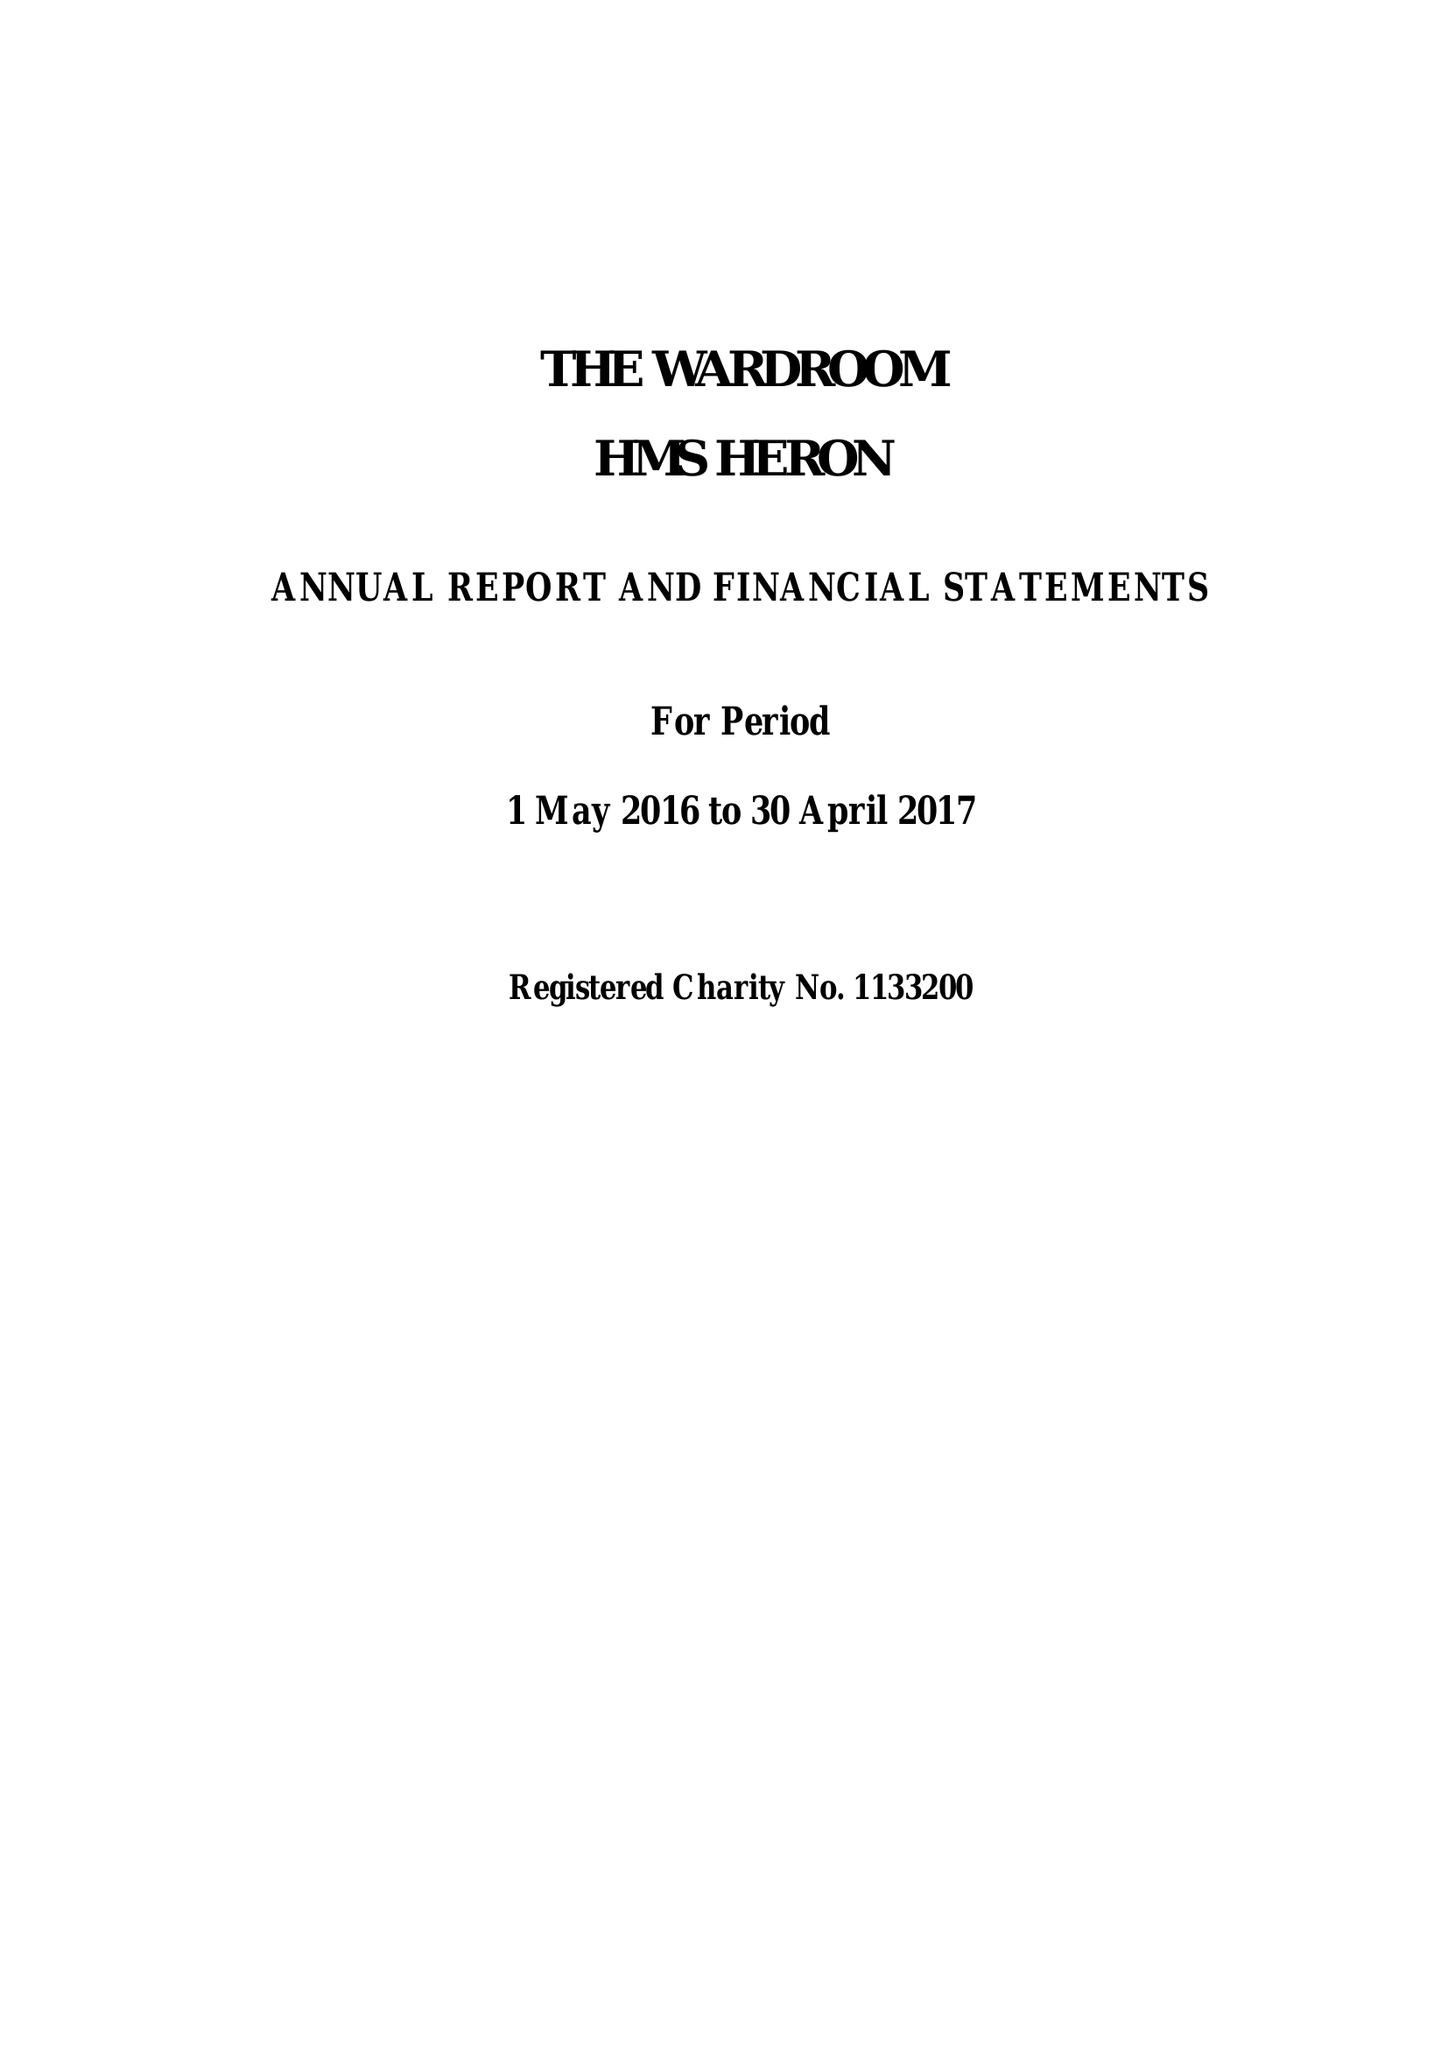What is the value for the address__street_line?
Answer the question using a single word or phrase. YEOVILTON 